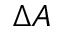Convert formula to latex. <formula><loc_0><loc_0><loc_500><loc_500>\Delta A</formula> 